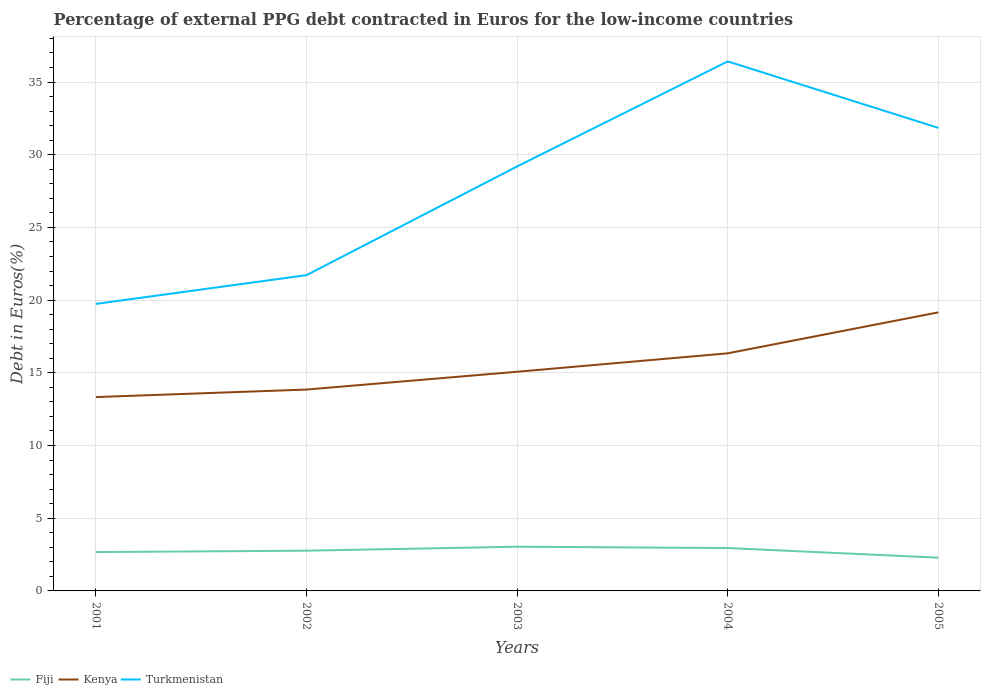Across all years, what is the maximum percentage of external PPG debt contracted in Euros in Kenya?
Ensure brevity in your answer.  13.33. What is the total percentage of external PPG debt contracted in Euros in Turkmenistan in the graph?
Give a very brief answer. -7.48. What is the difference between the highest and the second highest percentage of external PPG debt contracted in Euros in Turkmenistan?
Provide a short and direct response. 16.68. What is the difference between the highest and the lowest percentage of external PPG debt contracted in Euros in Kenya?
Your answer should be compact. 2. Is the percentage of external PPG debt contracted in Euros in Kenya strictly greater than the percentage of external PPG debt contracted in Euros in Turkmenistan over the years?
Provide a short and direct response. Yes. How many years are there in the graph?
Ensure brevity in your answer.  5. Are the values on the major ticks of Y-axis written in scientific E-notation?
Provide a short and direct response. No. Does the graph contain grids?
Ensure brevity in your answer.  Yes. Where does the legend appear in the graph?
Offer a very short reply. Bottom left. How are the legend labels stacked?
Offer a very short reply. Horizontal. What is the title of the graph?
Provide a succinct answer. Percentage of external PPG debt contracted in Euros for the low-income countries. What is the label or title of the Y-axis?
Make the answer very short. Debt in Euros(%). What is the Debt in Euros(%) of Fiji in 2001?
Offer a terse response. 2.67. What is the Debt in Euros(%) in Kenya in 2001?
Keep it short and to the point. 13.33. What is the Debt in Euros(%) of Turkmenistan in 2001?
Make the answer very short. 19.74. What is the Debt in Euros(%) in Fiji in 2002?
Your answer should be compact. 2.77. What is the Debt in Euros(%) in Kenya in 2002?
Provide a succinct answer. 13.85. What is the Debt in Euros(%) of Turkmenistan in 2002?
Your answer should be very brief. 21.72. What is the Debt in Euros(%) of Fiji in 2003?
Give a very brief answer. 3.04. What is the Debt in Euros(%) in Kenya in 2003?
Your answer should be compact. 15.07. What is the Debt in Euros(%) in Turkmenistan in 2003?
Offer a terse response. 29.19. What is the Debt in Euros(%) of Fiji in 2004?
Offer a terse response. 2.95. What is the Debt in Euros(%) in Kenya in 2004?
Provide a succinct answer. 16.34. What is the Debt in Euros(%) in Turkmenistan in 2004?
Your response must be concise. 36.42. What is the Debt in Euros(%) of Fiji in 2005?
Offer a terse response. 2.29. What is the Debt in Euros(%) in Kenya in 2005?
Ensure brevity in your answer.  19.16. What is the Debt in Euros(%) in Turkmenistan in 2005?
Give a very brief answer. 31.85. Across all years, what is the maximum Debt in Euros(%) in Fiji?
Make the answer very short. 3.04. Across all years, what is the maximum Debt in Euros(%) in Kenya?
Your response must be concise. 19.16. Across all years, what is the maximum Debt in Euros(%) in Turkmenistan?
Keep it short and to the point. 36.42. Across all years, what is the minimum Debt in Euros(%) of Fiji?
Provide a succinct answer. 2.29. Across all years, what is the minimum Debt in Euros(%) in Kenya?
Offer a very short reply. 13.33. Across all years, what is the minimum Debt in Euros(%) of Turkmenistan?
Your answer should be compact. 19.74. What is the total Debt in Euros(%) in Fiji in the graph?
Provide a succinct answer. 13.72. What is the total Debt in Euros(%) of Kenya in the graph?
Your answer should be very brief. 77.76. What is the total Debt in Euros(%) in Turkmenistan in the graph?
Offer a very short reply. 138.92. What is the difference between the Debt in Euros(%) in Fiji in 2001 and that in 2002?
Offer a very short reply. -0.09. What is the difference between the Debt in Euros(%) in Kenya in 2001 and that in 2002?
Give a very brief answer. -0.52. What is the difference between the Debt in Euros(%) in Turkmenistan in 2001 and that in 2002?
Offer a very short reply. -1.98. What is the difference between the Debt in Euros(%) of Fiji in 2001 and that in 2003?
Your answer should be compact. -0.37. What is the difference between the Debt in Euros(%) of Kenya in 2001 and that in 2003?
Keep it short and to the point. -1.74. What is the difference between the Debt in Euros(%) of Turkmenistan in 2001 and that in 2003?
Keep it short and to the point. -9.45. What is the difference between the Debt in Euros(%) in Fiji in 2001 and that in 2004?
Ensure brevity in your answer.  -0.28. What is the difference between the Debt in Euros(%) in Kenya in 2001 and that in 2004?
Provide a succinct answer. -3.01. What is the difference between the Debt in Euros(%) in Turkmenistan in 2001 and that in 2004?
Provide a succinct answer. -16.68. What is the difference between the Debt in Euros(%) of Fiji in 2001 and that in 2005?
Offer a terse response. 0.38. What is the difference between the Debt in Euros(%) of Kenya in 2001 and that in 2005?
Your response must be concise. -5.83. What is the difference between the Debt in Euros(%) of Turkmenistan in 2001 and that in 2005?
Offer a very short reply. -12.11. What is the difference between the Debt in Euros(%) in Fiji in 2002 and that in 2003?
Offer a terse response. -0.27. What is the difference between the Debt in Euros(%) of Kenya in 2002 and that in 2003?
Your answer should be very brief. -1.22. What is the difference between the Debt in Euros(%) in Turkmenistan in 2002 and that in 2003?
Provide a succinct answer. -7.48. What is the difference between the Debt in Euros(%) of Fiji in 2002 and that in 2004?
Give a very brief answer. -0.18. What is the difference between the Debt in Euros(%) in Kenya in 2002 and that in 2004?
Provide a short and direct response. -2.49. What is the difference between the Debt in Euros(%) in Turkmenistan in 2002 and that in 2004?
Your answer should be compact. -14.7. What is the difference between the Debt in Euros(%) of Fiji in 2002 and that in 2005?
Your response must be concise. 0.48. What is the difference between the Debt in Euros(%) of Kenya in 2002 and that in 2005?
Offer a terse response. -5.31. What is the difference between the Debt in Euros(%) of Turkmenistan in 2002 and that in 2005?
Keep it short and to the point. -10.13. What is the difference between the Debt in Euros(%) in Fiji in 2003 and that in 2004?
Provide a succinct answer. 0.09. What is the difference between the Debt in Euros(%) of Kenya in 2003 and that in 2004?
Keep it short and to the point. -1.27. What is the difference between the Debt in Euros(%) of Turkmenistan in 2003 and that in 2004?
Give a very brief answer. -7.23. What is the difference between the Debt in Euros(%) of Fiji in 2003 and that in 2005?
Offer a terse response. 0.75. What is the difference between the Debt in Euros(%) in Kenya in 2003 and that in 2005?
Your answer should be compact. -4.09. What is the difference between the Debt in Euros(%) of Turkmenistan in 2003 and that in 2005?
Keep it short and to the point. -2.65. What is the difference between the Debt in Euros(%) in Fiji in 2004 and that in 2005?
Keep it short and to the point. 0.66. What is the difference between the Debt in Euros(%) of Kenya in 2004 and that in 2005?
Your answer should be compact. -2.82. What is the difference between the Debt in Euros(%) in Turkmenistan in 2004 and that in 2005?
Your answer should be very brief. 4.57. What is the difference between the Debt in Euros(%) of Fiji in 2001 and the Debt in Euros(%) of Kenya in 2002?
Your response must be concise. -11.18. What is the difference between the Debt in Euros(%) in Fiji in 2001 and the Debt in Euros(%) in Turkmenistan in 2002?
Keep it short and to the point. -19.04. What is the difference between the Debt in Euros(%) of Kenya in 2001 and the Debt in Euros(%) of Turkmenistan in 2002?
Offer a terse response. -8.38. What is the difference between the Debt in Euros(%) in Fiji in 2001 and the Debt in Euros(%) in Kenya in 2003?
Your answer should be compact. -12.4. What is the difference between the Debt in Euros(%) of Fiji in 2001 and the Debt in Euros(%) of Turkmenistan in 2003?
Provide a succinct answer. -26.52. What is the difference between the Debt in Euros(%) in Kenya in 2001 and the Debt in Euros(%) in Turkmenistan in 2003?
Your answer should be compact. -15.86. What is the difference between the Debt in Euros(%) in Fiji in 2001 and the Debt in Euros(%) in Kenya in 2004?
Ensure brevity in your answer.  -13.67. What is the difference between the Debt in Euros(%) in Fiji in 2001 and the Debt in Euros(%) in Turkmenistan in 2004?
Make the answer very short. -33.75. What is the difference between the Debt in Euros(%) in Kenya in 2001 and the Debt in Euros(%) in Turkmenistan in 2004?
Keep it short and to the point. -23.09. What is the difference between the Debt in Euros(%) in Fiji in 2001 and the Debt in Euros(%) in Kenya in 2005?
Your answer should be very brief. -16.49. What is the difference between the Debt in Euros(%) of Fiji in 2001 and the Debt in Euros(%) of Turkmenistan in 2005?
Keep it short and to the point. -29.17. What is the difference between the Debt in Euros(%) in Kenya in 2001 and the Debt in Euros(%) in Turkmenistan in 2005?
Make the answer very short. -18.51. What is the difference between the Debt in Euros(%) of Fiji in 2002 and the Debt in Euros(%) of Kenya in 2003?
Your answer should be compact. -12.31. What is the difference between the Debt in Euros(%) in Fiji in 2002 and the Debt in Euros(%) in Turkmenistan in 2003?
Your response must be concise. -26.43. What is the difference between the Debt in Euros(%) in Kenya in 2002 and the Debt in Euros(%) in Turkmenistan in 2003?
Your answer should be compact. -15.34. What is the difference between the Debt in Euros(%) of Fiji in 2002 and the Debt in Euros(%) of Kenya in 2004?
Ensure brevity in your answer.  -13.57. What is the difference between the Debt in Euros(%) in Fiji in 2002 and the Debt in Euros(%) in Turkmenistan in 2004?
Your response must be concise. -33.65. What is the difference between the Debt in Euros(%) in Kenya in 2002 and the Debt in Euros(%) in Turkmenistan in 2004?
Provide a short and direct response. -22.57. What is the difference between the Debt in Euros(%) in Fiji in 2002 and the Debt in Euros(%) in Kenya in 2005?
Ensure brevity in your answer.  -16.39. What is the difference between the Debt in Euros(%) in Fiji in 2002 and the Debt in Euros(%) in Turkmenistan in 2005?
Make the answer very short. -29.08. What is the difference between the Debt in Euros(%) of Kenya in 2002 and the Debt in Euros(%) of Turkmenistan in 2005?
Offer a terse response. -18. What is the difference between the Debt in Euros(%) in Fiji in 2003 and the Debt in Euros(%) in Kenya in 2004?
Offer a very short reply. -13.3. What is the difference between the Debt in Euros(%) of Fiji in 2003 and the Debt in Euros(%) of Turkmenistan in 2004?
Your response must be concise. -33.38. What is the difference between the Debt in Euros(%) of Kenya in 2003 and the Debt in Euros(%) of Turkmenistan in 2004?
Your answer should be very brief. -21.35. What is the difference between the Debt in Euros(%) of Fiji in 2003 and the Debt in Euros(%) of Kenya in 2005?
Offer a terse response. -16.12. What is the difference between the Debt in Euros(%) of Fiji in 2003 and the Debt in Euros(%) of Turkmenistan in 2005?
Your answer should be very brief. -28.81. What is the difference between the Debt in Euros(%) in Kenya in 2003 and the Debt in Euros(%) in Turkmenistan in 2005?
Offer a very short reply. -16.77. What is the difference between the Debt in Euros(%) of Fiji in 2004 and the Debt in Euros(%) of Kenya in 2005?
Make the answer very short. -16.21. What is the difference between the Debt in Euros(%) in Fiji in 2004 and the Debt in Euros(%) in Turkmenistan in 2005?
Your answer should be very brief. -28.9. What is the difference between the Debt in Euros(%) in Kenya in 2004 and the Debt in Euros(%) in Turkmenistan in 2005?
Give a very brief answer. -15.51. What is the average Debt in Euros(%) in Fiji per year?
Provide a short and direct response. 2.74. What is the average Debt in Euros(%) in Kenya per year?
Provide a short and direct response. 15.55. What is the average Debt in Euros(%) of Turkmenistan per year?
Keep it short and to the point. 27.78. In the year 2001, what is the difference between the Debt in Euros(%) of Fiji and Debt in Euros(%) of Kenya?
Give a very brief answer. -10.66. In the year 2001, what is the difference between the Debt in Euros(%) of Fiji and Debt in Euros(%) of Turkmenistan?
Keep it short and to the point. -17.07. In the year 2001, what is the difference between the Debt in Euros(%) in Kenya and Debt in Euros(%) in Turkmenistan?
Offer a terse response. -6.41. In the year 2002, what is the difference between the Debt in Euros(%) of Fiji and Debt in Euros(%) of Kenya?
Provide a succinct answer. -11.08. In the year 2002, what is the difference between the Debt in Euros(%) in Fiji and Debt in Euros(%) in Turkmenistan?
Provide a short and direct response. -18.95. In the year 2002, what is the difference between the Debt in Euros(%) of Kenya and Debt in Euros(%) of Turkmenistan?
Your answer should be compact. -7.87. In the year 2003, what is the difference between the Debt in Euros(%) in Fiji and Debt in Euros(%) in Kenya?
Your answer should be compact. -12.03. In the year 2003, what is the difference between the Debt in Euros(%) of Fiji and Debt in Euros(%) of Turkmenistan?
Keep it short and to the point. -26.15. In the year 2003, what is the difference between the Debt in Euros(%) in Kenya and Debt in Euros(%) in Turkmenistan?
Your answer should be compact. -14.12. In the year 2004, what is the difference between the Debt in Euros(%) in Fiji and Debt in Euros(%) in Kenya?
Ensure brevity in your answer.  -13.39. In the year 2004, what is the difference between the Debt in Euros(%) of Fiji and Debt in Euros(%) of Turkmenistan?
Ensure brevity in your answer.  -33.47. In the year 2004, what is the difference between the Debt in Euros(%) of Kenya and Debt in Euros(%) of Turkmenistan?
Provide a short and direct response. -20.08. In the year 2005, what is the difference between the Debt in Euros(%) of Fiji and Debt in Euros(%) of Kenya?
Provide a succinct answer. -16.87. In the year 2005, what is the difference between the Debt in Euros(%) in Fiji and Debt in Euros(%) in Turkmenistan?
Provide a short and direct response. -29.56. In the year 2005, what is the difference between the Debt in Euros(%) of Kenya and Debt in Euros(%) of Turkmenistan?
Keep it short and to the point. -12.69. What is the ratio of the Debt in Euros(%) in Fiji in 2001 to that in 2002?
Offer a very short reply. 0.97. What is the ratio of the Debt in Euros(%) of Kenya in 2001 to that in 2002?
Ensure brevity in your answer.  0.96. What is the ratio of the Debt in Euros(%) in Turkmenistan in 2001 to that in 2002?
Make the answer very short. 0.91. What is the ratio of the Debt in Euros(%) in Fiji in 2001 to that in 2003?
Keep it short and to the point. 0.88. What is the ratio of the Debt in Euros(%) of Kenya in 2001 to that in 2003?
Provide a succinct answer. 0.88. What is the ratio of the Debt in Euros(%) of Turkmenistan in 2001 to that in 2003?
Keep it short and to the point. 0.68. What is the ratio of the Debt in Euros(%) of Fiji in 2001 to that in 2004?
Keep it short and to the point. 0.91. What is the ratio of the Debt in Euros(%) in Kenya in 2001 to that in 2004?
Keep it short and to the point. 0.82. What is the ratio of the Debt in Euros(%) of Turkmenistan in 2001 to that in 2004?
Make the answer very short. 0.54. What is the ratio of the Debt in Euros(%) of Fiji in 2001 to that in 2005?
Keep it short and to the point. 1.17. What is the ratio of the Debt in Euros(%) of Kenya in 2001 to that in 2005?
Make the answer very short. 0.7. What is the ratio of the Debt in Euros(%) of Turkmenistan in 2001 to that in 2005?
Your answer should be compact. 0.62. What is the ratio of the Debt in Euros(%) of Fiji in 2002 to that in 2003?
Provide a short and direct response. 0.91. What is the ratio of the Debt in Euros(%) of Kenya in 2002 to that in 2003?
Ensure brevity in your answer.  0.92. What is the ratio of the Debt in Euros(%) of Turkmenistan in 2002 to that in 2003?
Make the answer very short. 0.74. What is the ratio of the Debt in Euros(%) in Fiji in 2002 to that in 2004?
Offer a very short reply. 0.94. What is the ratio of the Debt in Euros(%) in Kenya in 2002 to that in 2004?
Make the answer very short. 0.85. What is the ratio of the Debt in Euros(%) in Turkmenistan in 2002 to that in 2004?
Offer a very short reply. 0.6. What is the ratio of the Debt in Euros(%) of Fiji in 2002 to that in 2005?
Keep it short and to the point. 1.21. What is the ratio of the Debt in Euros(%) of Kenya in 2002 to that in 2005?
Offer a terse response. 0.72. What is the ratio of the Debt in Euros(%) of Turkmenistan in 2002 to that in 2005?
Provide a short and direct response. 0.68. What is the ratio of the Debt in Euros(%) of Fiji in 2003 to that in 2004?
Provide a short and direct response. 1.03. What is the ratio of the Debt in Euros(%) in Kenya in 2003 to that in 2004?
Your response must be concise. 0.92. What is the ratio of the Debt in Euros(%) in Turkmenistan in 2003 to that in 2004?
Your answer should be compact. 0.8. What is the ratio of the Debt in Euros(%) in Fiji in 2003 to that in 2005?
Keep it short and to the point. 1.33. What is the ratio of the Debt in Euros(%) of Kenya in 2003 to that in 2005?
Make the answer very short. 0.79. What is the ratio of the Debt in Euros(%) of Turkmenistan in 2003 to that in 2005?
Give a very brief answer. 0.92. What is the ratio of the Debt in Euros(%) of Fiji in 2004 to that in 2005?
Your response must be concise. 1.29. What is the ratio of the Debt in Euros(%) in Kenya in 2004 to that in 2005?
Provide a short and direct response. 0.85. What is the ratio of the Debt in Euros(%) in Turkmenistan in 2004 to that in 2005?
Keep it short and to the point. 1.14. What is the difference between the highest and the second highest Debt in Euros(%) in Fiji?
Your answer should be very brief. 0.09. What is the difference between the highest and the second highest Debt in Euros(%) in Kenya?
Provide a succinct answer. 2.82. What is the difference between the highest and the second highest Debt in Euros(%) of Turkmenistan?
Offer a very short reply. 4.57. What is the difference between the highest and the lowest Debt in Euros(%) in Fiji?
Ensure brevity in your answer.  0.75. What is the difference between the highest and the lowest Debt in Euros(%) of Kenya?
Make the answer very short. 5.83. What is the difference between the highest and the lowest Debt in Euros(%) in Turkmenistan?
Your answer should be compact. 16.68. 